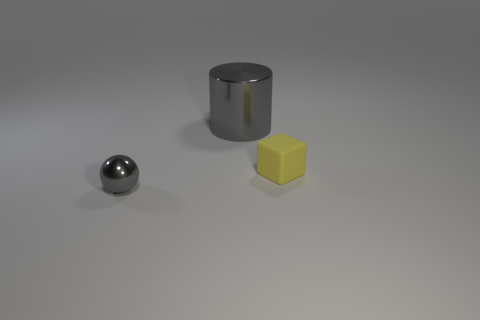There is a gray metal object behind the tiny thing on the left side of the big gray metallic thing; what size is it?
Offer a terse response. Large. Is there anything else of the same color as the small metallic thing?
Make the answer very short. Yes. Is the gray object that is behind the small shiny object made of the same material as the small thing behind the tiny gray ball?
Ensure brevity in your answer.  No. What is the material of the thing that is to the right of the gray shiny ball and in front of the gray cylinder?
Offer a terse response. Rubber. Do the big object and the gray metal object that is in front of the tiny yellow thing have the same shape?
Keep it short and to the point. No. What material is the object that is right of the shiny object that is behind the tiny thing that is right of the small gray metallic sphere?
Provide a short and direct response. Rubber. How many other things are the same size as the yellow rubber block?
Provide a short and direct response. 1. Do the metallic cylinder and the small ball have the same color?
Ensure brevity in your answer.  Yes. There is a gray metallic object on the right side of the thing in front of the small yellow matte object; what number of big gray shiny cylinders are right of it?
Provide a short and direct response. 0. The gray thing in front of the thing behind the yellow block is made of what material?
Make the answer very short. Metal. 